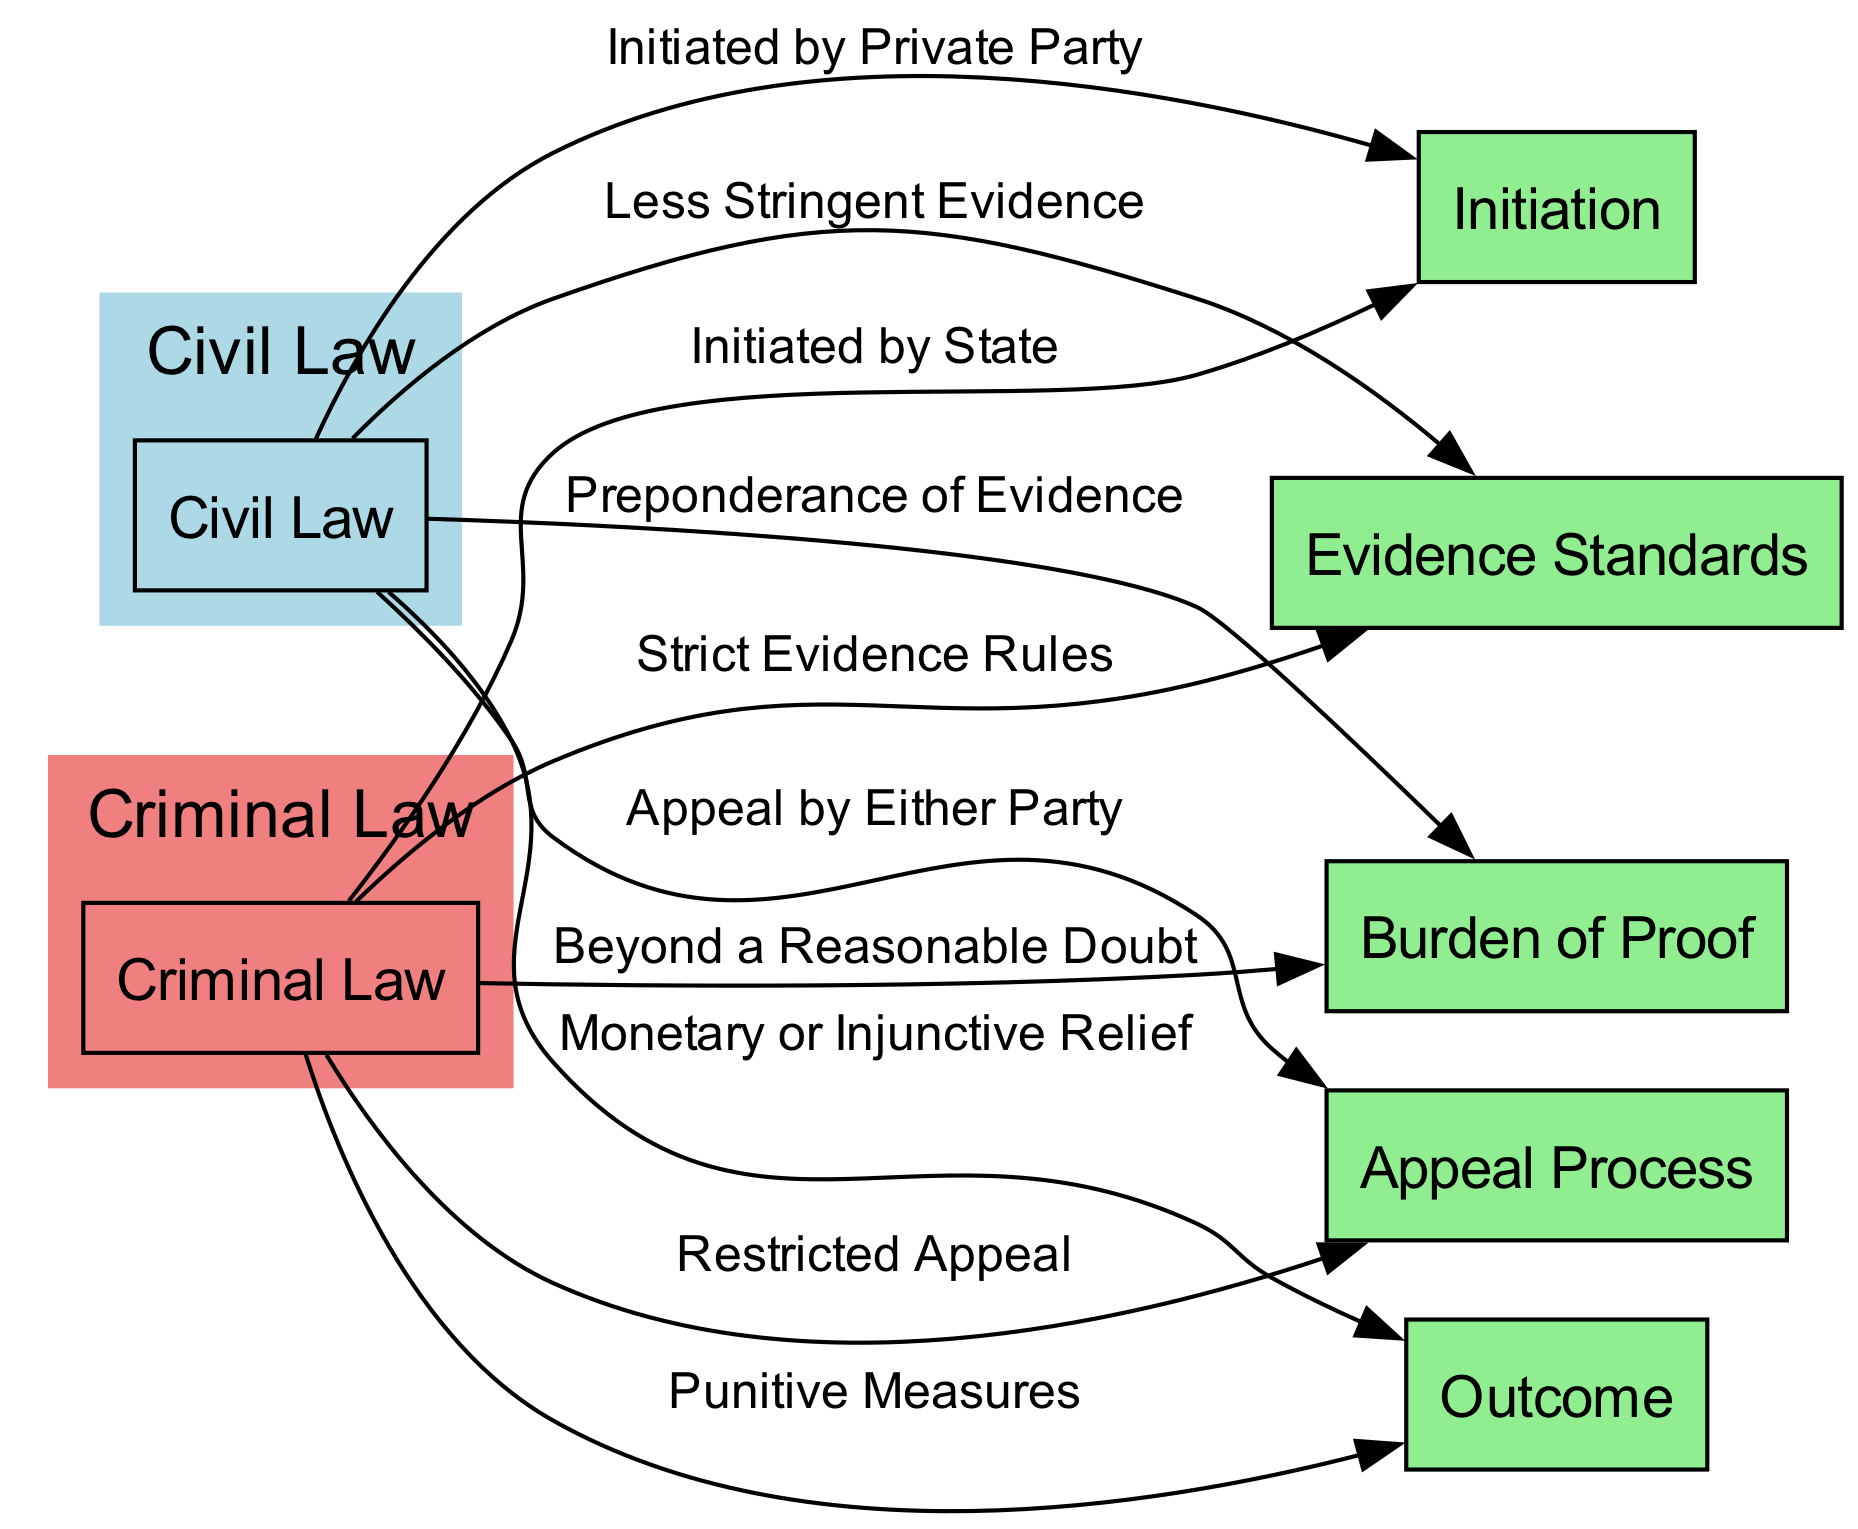What initiates a civil law case? The diagram indicates that a civil law case is "Initiated by Private Party" as shown in the edge connecting "Civil Law" to "Initiation."
Answer: Initiated by Private Party What is the burden of proof in criminal law? According to the diagram, criminal law's burden of proof is "Beyond a Reasonable Doubt," which connects "Criminal Law" to "Burden of Proof."
Answer: Beyond a Reasonable Doubt How many nodes are there in the diagram? The diagram contains a total of 7 nodes, as counted from the list provided.
Answer: 7 What is the outcome of civil law procedures? From the diagram, civil law outcomes lead to "Monetary or Injunctive Relief," visible in the edge from "Civil Law" to "Outcome."
Answer: Monetary or Injunctive Relief What type of appeal process exists in criminal law? The diagram shows that the appeal process in criminal law is "Restricted Appeal," which is linked from "Criminal Law" to "Appeal Process."
Answer: Restricted Appeal Which law has strict evidence rules? The edge from "Criminal Law" to "Evidence Standards" indicates that "Strict Evidence Rules" apply to criminal law.
Answer: Strict Evidence Rules What kind of initiation does criminal law require? The diagram specifies that criminal law is "Initiated by State," reflecting this relationship on the edge from "Criminal Law" to "Initiation."
Answer: Initiated by State How is the outcome of criminal law characterized? It is illustrated in the diagram that the outcome of criminal law procedures leads to "Punitive Measures," connecting "Criminal Law" with "Outcome."
Answer: Punitive Measures What party can appeal in civil law? The diagram shows that in civil law, the "Appeal by Either Party," signaling that both parties have the right to appeal.
Answer: Either Party 